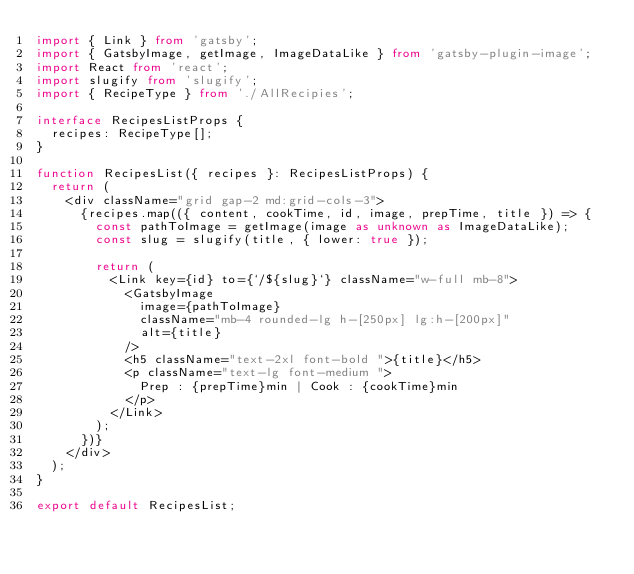Convert code to text. <code><loc_0><loc_0><loc_500><loc_500><_TypeScript_>import { Link } from 'gatsby';
import { GatsbyImage, getImage, ImageDataLike } from 'gatsby-plugin-image';
import React from 'react';
import slugify from 'slugify';
import { RecipeType } from './AllRecipies';

interface RecipesListProps {
  recipes: RecipeType[];
}

function RecipesList({ recipes }: RecipesListProps) {
  return (
    <div className="grid gap-2 md:grid-cols-3">
      {recipes.map(({ content, cookTime, id, image, prepTime, title }) => {
        const pathToImage = getImage(image as unknown as ImageDataLike);
        const slug = slugify(title, { lower: true });

        return (
          <Link key={id} to={`/${slug}`} className="w-full mb-8">
            <GatsbyImage
              image={pathToImage}
              className="mb-4 rounded-lg h-[250px] lg:h-[200px]"
              alt={title}
            />
            <h5 className="text-2xl font-bold ">{title}</h5>
            <p className="text-lg font-medium ">
              Prep : {prepTime}min | Cook : {cookTime}min
            </p>
          </Link>
        );
      })}
    </div>
  );
}

export default RecipesList;
</code> 